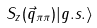<formula> <loc_0><loc_0><loc_500><loc_500>S _ { z } ( \vec { q } _ { \pi \pi } ) | g . s . \rangle</formula> 